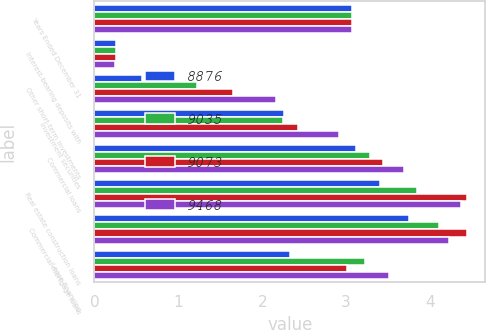<chart> <loc_0><loc_0><loc_500><loc_500><stacked_bar_chart><ecel><fcel>Years Ended December 31<fcel>Interest-bearing deposits with<fcel>Other short-term investments<fcel>Investment securities<fcel>Commercial loans<fcel>Real estate construction loans<fcel>Commercial mortgage loans<fcel>Lease financing<nl><fcel>8876<fcel>3.065<fcel>0.26<fcel>0.57<fcel>2.26<fcel>3.12<fcel>3.41<fcel>3.75<fcel>2.33<nl><fcel>9035<fcel>3.065<fcel>0.26<fcel>1.22<fcel>2.25<fcel>3.28<fcel>3.85<fcel>4.11<fcel>3.23<nl><fcel>9073<fcel>3.065<fcel>0.26<fcel>1.65<fcel>2.43<fcel>3.44<fcel>4.44<fcel>4.44<fcel>3.01<nl><fcel>9468<fcel>3.065<fcel>0.24<fcel>2.17<fcel>2.91<fcel>3.69<fcel>4.37<fcel>4.23<fcel>3.51<nl></chart> 